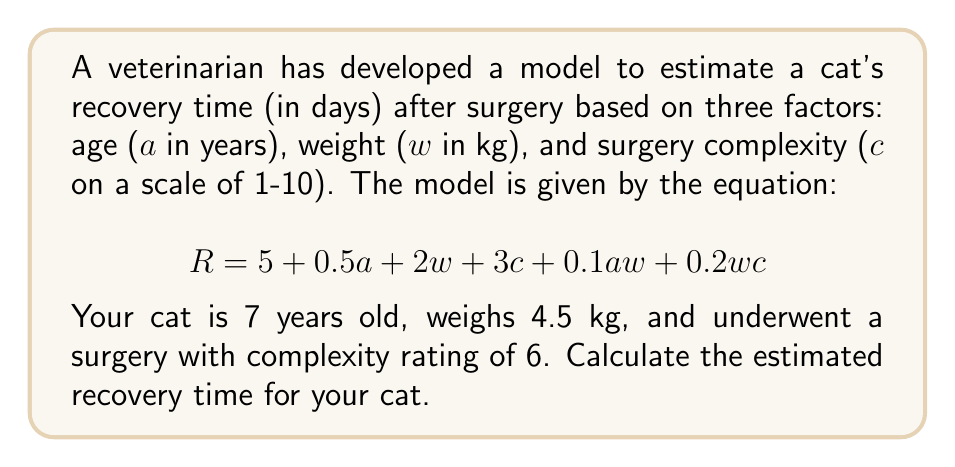Can you solve this math problem? Let's approach this step-by-step:

1) We have the following information:
   - Age ($a$) = 7 years
   - Weight ($w$) = 4.5 kg
   - Surgery complexity ($c$) = 6

2) Let's substitute these values into the equation:

   $$R = 5 + 0.5a + 2w + 3c + 0.1aw + 0.2wc$$

3) Substituting the values:

   $$R = 5 + 0.5(7) + 2(4.5) + 3(6) + 0.1(7)(4.5) + 0.2(4.5)(6)$$

4) Let's calculate each term:
   - $5 = 5$
   - $0.5(7) = 3.5$
   - $2(4.5) = 9$
   - $3(6) = 18$
   - $0.1(7)(4.5) = 3.15$
   - $0.2(4.5)(6) = 5.4$

5) Now, let's sum all these terms:

   $$R = 5 + 3.5 + 9 + 18 + 3.15 + 5.4 = 44.05$$

6) Since we're dealing with days, we should round to the nearest whole number.

Therefore, the estimated recovery time is 44 days.
Answer: 44 days 